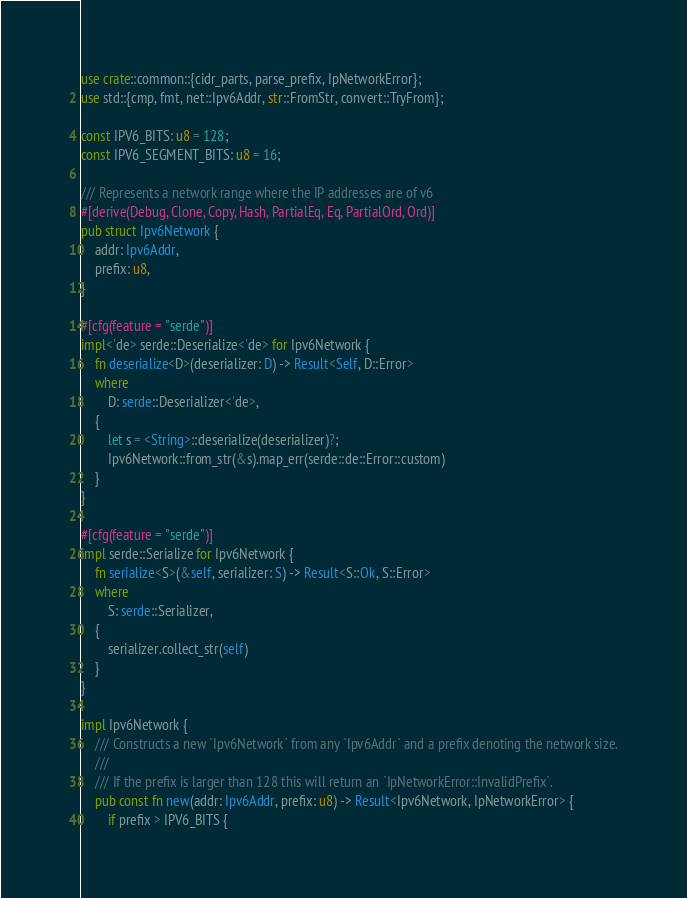Convert code to text. <code><loc_0><loc_0><loc_500><loc_500><_Rust_>use crate::common::{cidr_parts, parse_prefix, IpNetworkError};
use std::{cmp, fmt, net::Ipv6Addr, str::FromStr, convert::TryFrom};

const IPV6_BITS: u8 = 128;
const IPV6_SEGMENT_BITS: u8 = 16;

/// Represents a network range where the IP addresses are of v6
#[derive(Debug, Clone, Copy, Hash, PartialEq, Eq, PartialOrd, Ord)]
pub struct Ipv6Network {
    addr: Ipv6Addr,
    prefix: u8,
}

#[cfg(feature = "serde")]
impl<'de> serde::Deserialize<'de> for Ipv6Network {
    fn deserialize<D>(deserializer: D) -> Result<Self, D::Error>
    where
        D: serde::Deserializer<'de>,
    {
        let s = <String>::deserialize(deserializer)?;
        Ipv6Network::from_str(&s).map_err(serde::de::Error::custom)
    }
}

#[cfg(feature = "serde")]
impl serde::Serialize for Ipv6Network {
    fn serialize<S>(&self, serializer: S) -> Result<S::Ok, S::Error>
    where
        S: serde::Serializer,
    {
        serializer.collect_str(self)
    }
}

impl Ipv6Network {
    /// Constructs a new `Ipv6Network` from any `Ipv6Addr` and a prefix denoting the network size.
    ///
    /// If the prefix is larger than 128 this will return an `IpNetworkError::InvalidPrefix`.
    pub const fn new(addr: Ipv6Addr, prefix: u8) -> Result<Ipv6Network, IpNetworkError> {
        if prefix > IPV6_BITS {</code> 